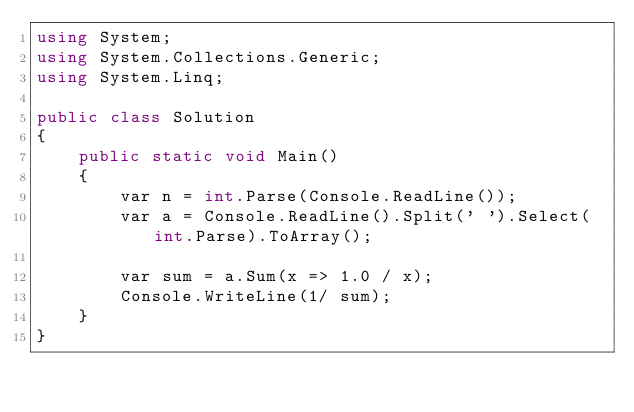<code> <loc_0><loc_0><loc_500><loc_500><_C#_>using System;
using System.Collections.Generic;
using System.Linq;

public class Solution
{
    public static void Main()
    {
        var n = int.Parse(Console.ReadLine());
        var a = Console.ReadLine().Split(' ').Select(int.Parse).ToArray();

        var sum = a.Sum(x => 1.0 / x);
        Console.WriteLine(1/ sum);
    }
}</code> 